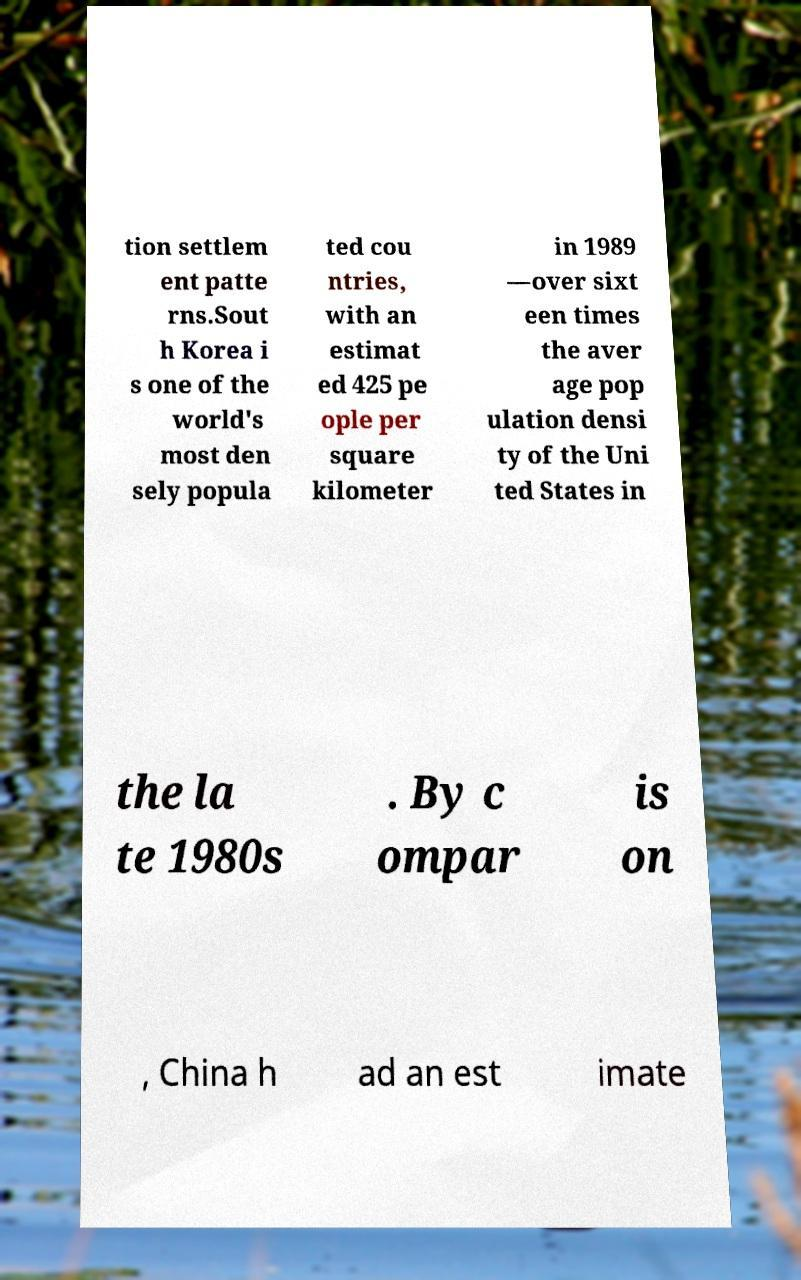What messages or text are displayed in this image? I need them in a readable, typed format. tion settlem ent patte rns.Sout h Korea i s one of the world's most den sely popula ted cou ntries, with an estimat ed 425 pe ople per square kilometer in 1989 —over sixt een times the aver age pop ulation densi ty of the Uni ted States in the la te 1980s . By c ompar is on , China h ad an est imate 